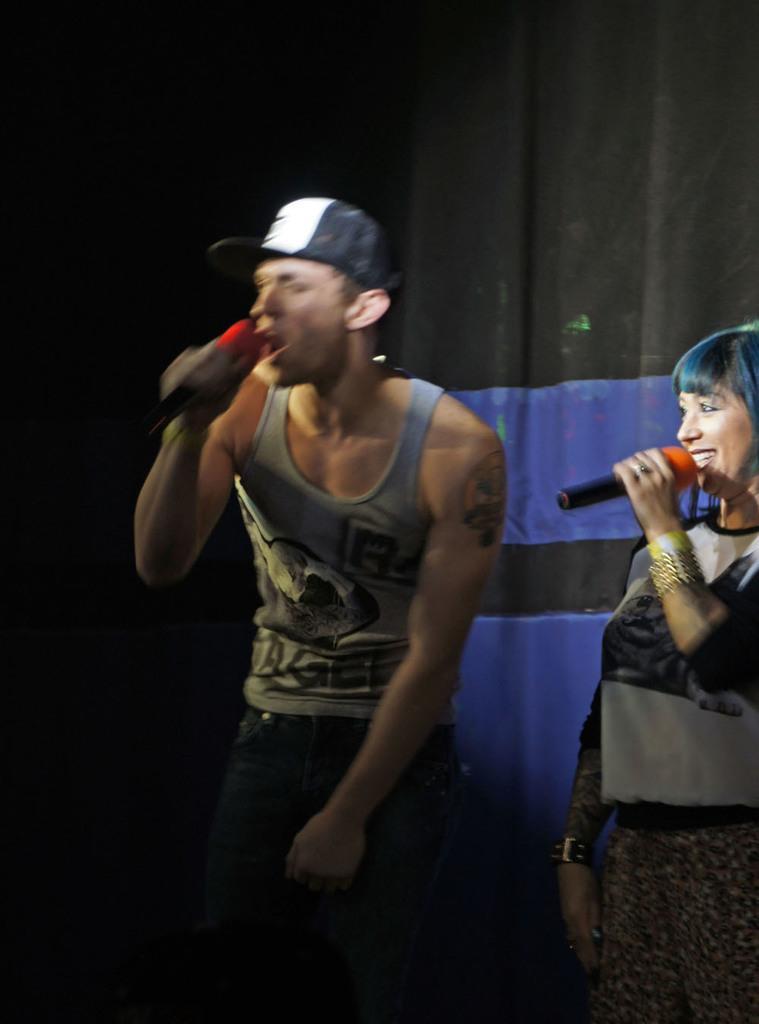How would you summarize this image in a sentence or two? This man is holding mic and singing. This woman is holding mic and smiling. This is curtain. 